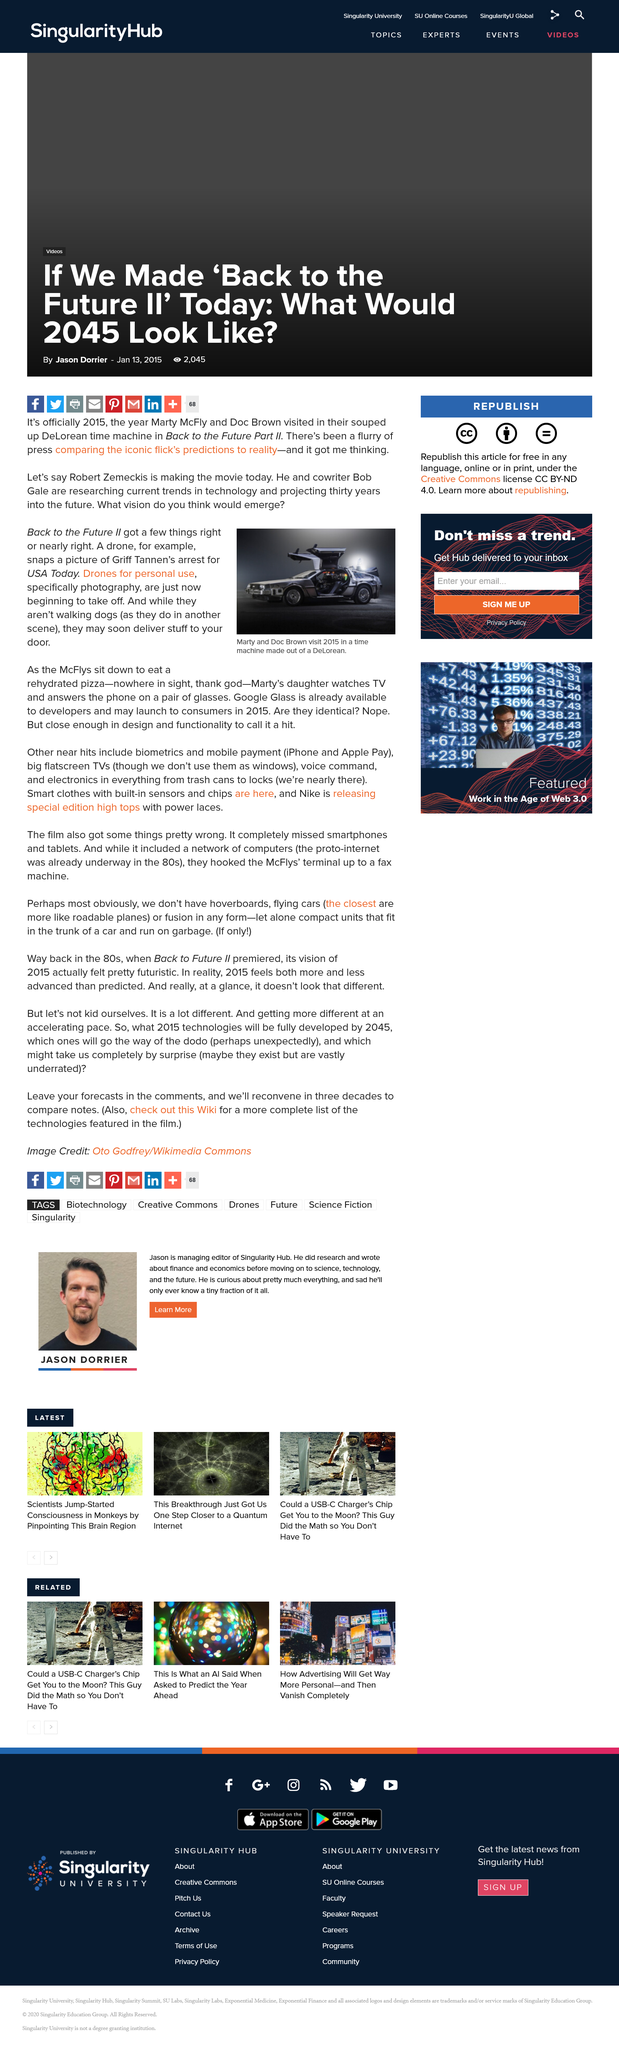Give some essential details in this illustration. In the year 2015, Marty and Doc Brown visited using a DeLorean time machine. A drone took a picture of Griff Tannen's arrest, which was later featured in USA Today. The director of Back to the Future Part II was Robert Zemeckis. 